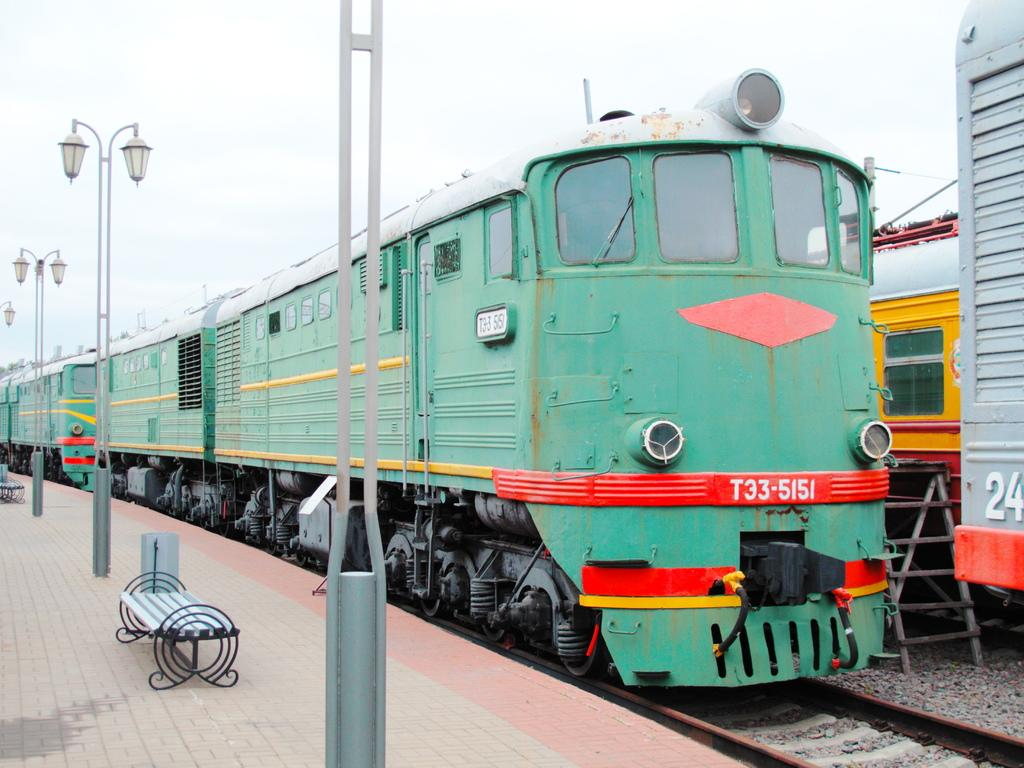<image>
Present a compact description of the photo's key features. A turquoise colored train is labeled with the number T33-5151. 